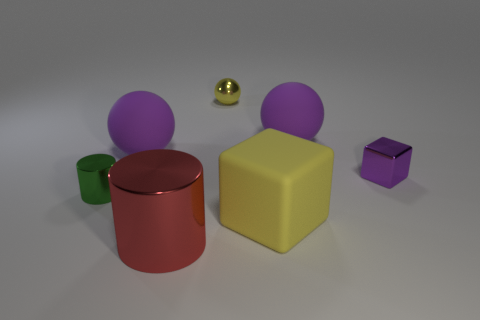What shapes are visible in the image? In the image, we observe a variety of geometric shapes including a couple of spheres, a cylinder, a cube, and a cuboid. 